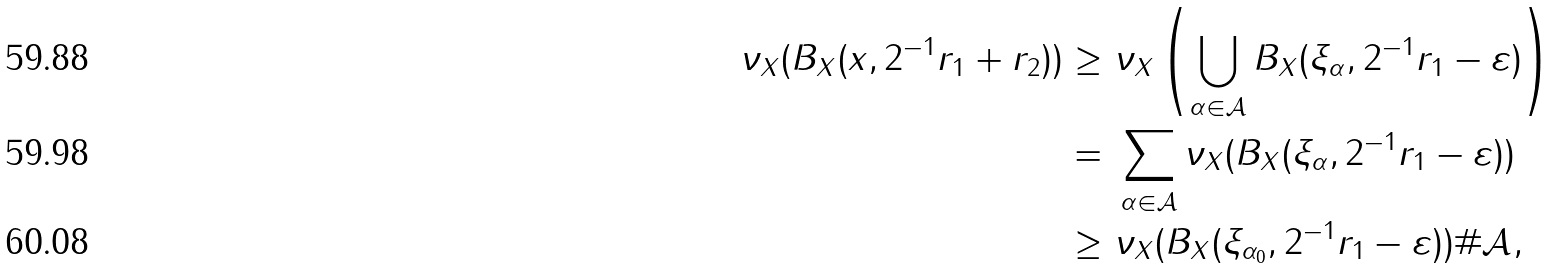Convert formula to latex. <formula><loc_0><loc_0><loc_500><loc_500>\nu _ { X } ( B _ { X } ( x , 2 ^ { - 1 } r _ { 1 } + r _ { 2 } ) ) \geq \ & \nu _ { X } \left ( \bigcup _ { \alpha \in \mathcal { A } } B _ { X } ( \xi _ { \alpha } , 2 ^ { - 1 } r _ { 1 } - \varepsilon ) \right ) \\ = \ & \sum _ { \alpha \in \mathcal { A } } \nu _ { X } ( B _ { X } ( \xi _ { \alpha } , 2 ^ { - 1 } r _ { 1 } - \varepsilon ) ) \\ \geq \ & \nu _ { X } ( B _ { X } ( \xi _ { \alpha _ { 0 } } , 2 ^ { - 1 } r _ { 1 } - \varepsilon ) ) \# \mathcal { A } ,</formula> 